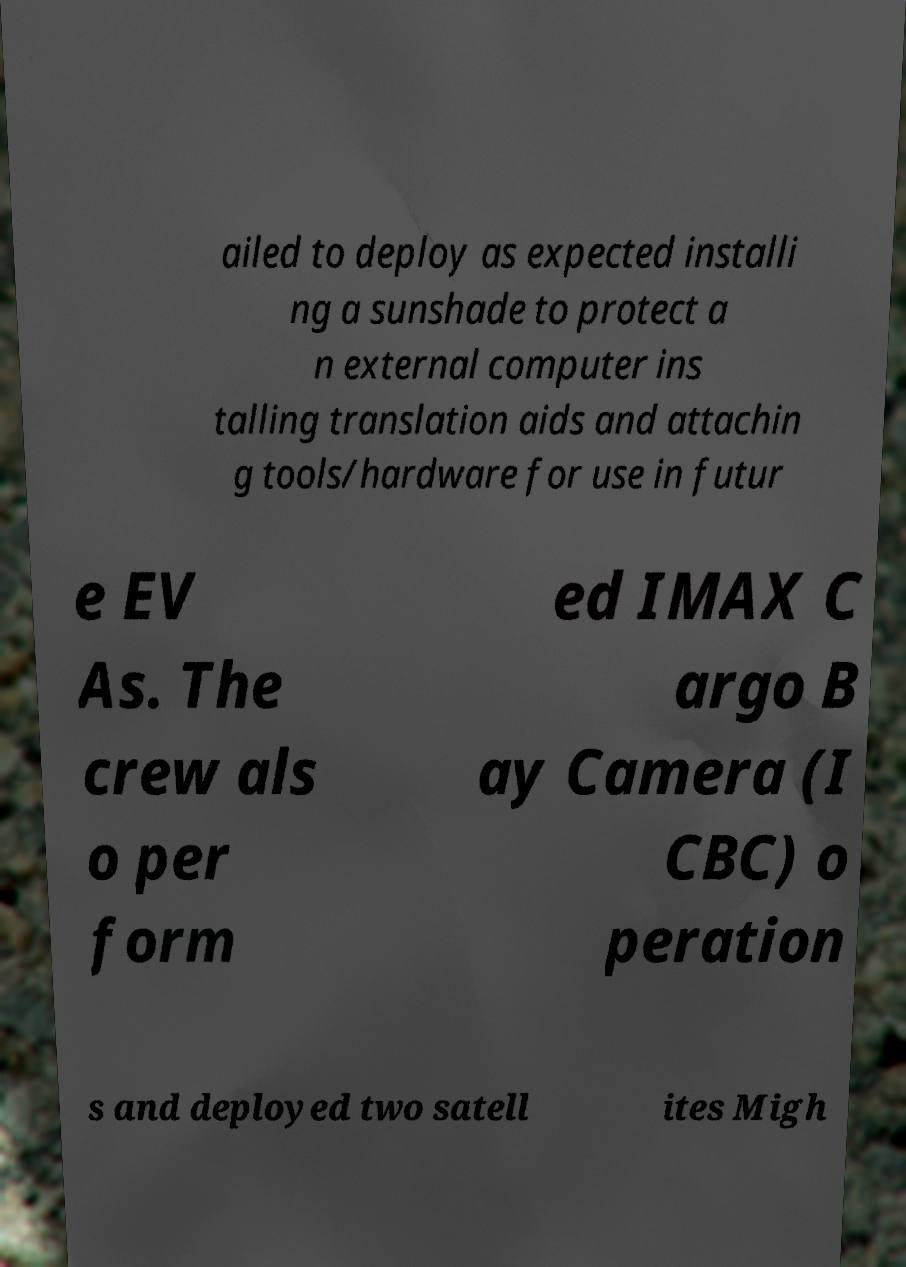Can you read and provide the text displayed in the image?This photo seems to have some interesting text. Can you extract and type it out for me? ailed to deploy as expected installi ng a sunshade to protect a n external computer ins talling translation aids and attachin g tools/hardware for use in futur e EV As. The crew als o per form ed IMAX C argo B ay Camera (I CBC) o peration s and deployed two satell ites Migh 